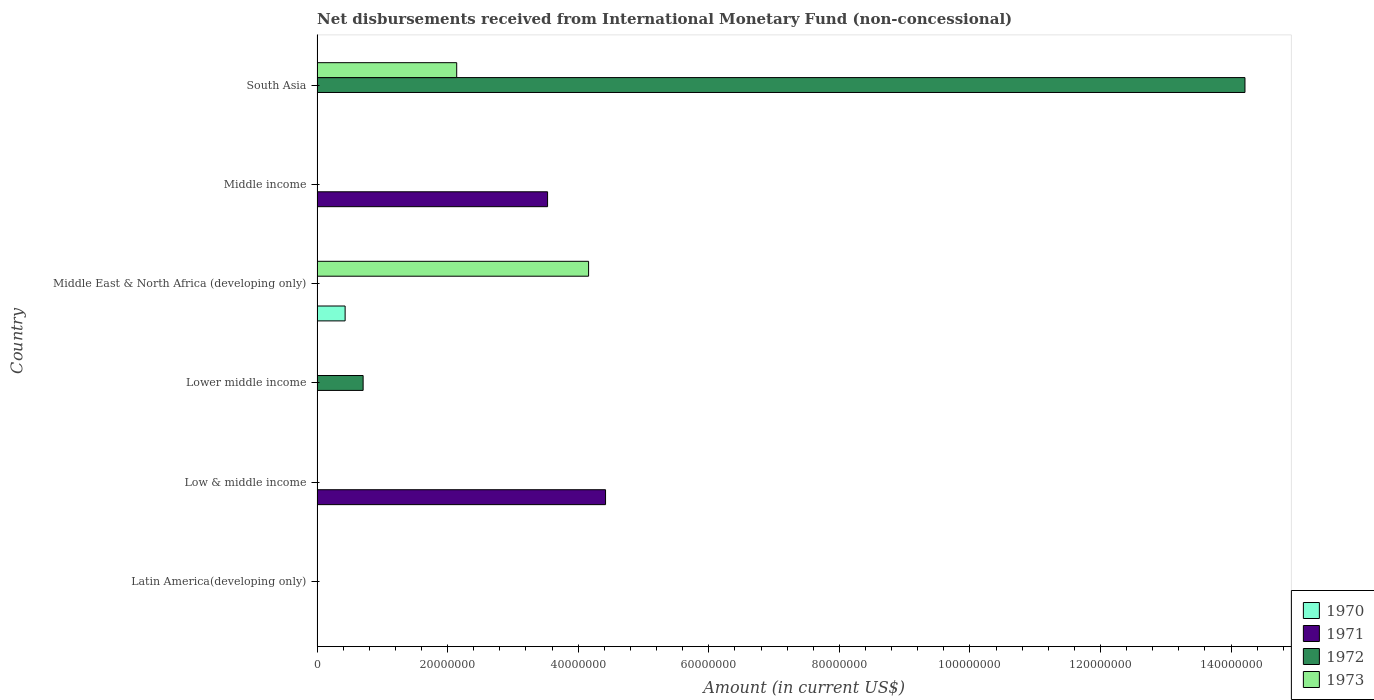How many different coloured bars are there?
Keep it short and to the point. 4. Are the number of bars per tick equal to the number of legend labels?
Provide a short and direct response. No. Are the number of bars on each tick of the Y-axis equal?
Ensure brevity in your answer.  No. Across all countries, what is the maximum amount of disbursements received from International Monetary Fund in 1972?
Your response must be concise. 1.42e+08. In which country was the amount of disbursements received from International Monetary Fund in 1971 maximum?
Your response must be concise. Low & middle income. What is the total amount of disbursements received from International Monetary Fund in 1970 in the graph?
Provide a short and direct response. 4.30e+06. What is the difference between the amount of disbursements received from International Monetary Fund in 1973 in South Asia and the amount of disbursements received from International Monetary Fund in 1972 in Middle income?
Your response must be concise. 2.14e+07. What is the average amount of disbursements received from International Monetary Fund in 1971 per country?
Provide a succinct answer. 1.32e+07. What is the difference between the amount of disbursements received from International Monetary Fund in 1973 and amount of disbursements received from International Monetary Fund in 1972 in South Asia?
Make the answer very short. -1.21e+08. What is the ratio of the amount of disbursements received from International Monetary Fund in 1971 in Low & middle income to that in Middle income?
Offer a terse response. 1.25. What is the difference between the highest and the lowest amount of disbursements received from International Monetary Fund in 1970?
Your answer should be very brief. 4.30e+06. Is it the case that in every country, the sum of the amount of disbursements received from International Monetary Fund in 1971 and amount of disbursements received from International Monetary Fund in 1972 is greater than the sum of amount of disbursements received from International Monetary Fund in 1970 and amount of disbursements received from International Monetary Fund in 1973?
Provide a succinct answer. No. Is it the case that in every country, the sum of the amount of disbursements received from International Monetary Fund in 1971 and amount of disbursements received from International Monetary Fund in 1972 is greater than the amount of disbursements received from International Monetary Fund in 1970?
Provide a short and direct response. No. How many bars are there?
Ensure brevity in your answer.  7. Are all the bars in the graph horizontal?
Your response must be concise. Yes. Are the values on the major ticks of X-axis written in scientific E-notation?
Offer a terse response. No. Does the graph contain any zero values?
Ensure brevity in your answer.  Yes. Does the graph contain grids?
Offer a very short reply. No. Where does the legend appear in the graph?
Ensure brevity in your answer.  Bottom right. How many legend labels are there?
Your answer should be very brief. 4. What is the title of the graph?
Your response must be concise. Net disbursements received from International Monetary Fund (non-concessional). What is the label or title of the X-axis?
Offer a terse response. Amount (in current US$). What is the Amount (in current US$) in 1970 in Latin America(developing only)?
Your answer should be compact. 0. What is the Amount (in current US$) in 1972 in Latin America(developing only)?
Keep it short and to the point. 0. What is the Amount (in current US$) in 1973 in Latin America(developing only)?
Make the answer very short. 0. What is the Amount (in current US$) of 1971 in Low & middle income?
Provide a succinct answer. 4.42e+07. What is the Amount (in current US$) in 1971 in Lower middle income?
Your answer should be very brief. 0. What is the Amount (in current US$) of 1972 in Lower middle income?
Offer a terse response. 7.06e+06. What is the Amount (in current US$) of 1973 in Lower middle income?
Provide a short and direct response. 0. What is the Amount (in current US$) of 1970 in Middle East & North Africa (developing only)?
Provide a short and direct response. 4.30e+06. What is the Amount (in current US$) of 1971 in Middle East & North Africa (developing only)?
Offer a very short reply. 0. What is the Amount (in current US$) of 1972 in Middle East & North Africa (developing only)?
Offer a terse response. 0. What is the Amount (in current US$) of 1973 in Middle East & North Africa (developing only)?
Your answer should be compact. 4.16e+07. What is the Amount (in current US$) of 1970 in Middle income?
Make the answer very short. 0. What is the Amount (in current US$) in 1971 in Middle income?
Give a very brief answer. 3.53e+07. What is the Amount (in current US$) in 1972 in Middle income?
Make the answer very short. 0. What is the Amount (in current US$) in 1972 in South Asia?
Your response must be concise. 1.42e+08. What is the Amount (in current US$) of 1973 in South Asia?
Give a very brief answer. 2.14e+07. Across all countries, what is the maximum Amount (in current US$) in 1970?
Your response must be concise. 4.30e+06. Across all countries, what is the maximum Amount (in current US$) of 1971?
Keep it short and to the point. 4.42e+07. Across all countries, what is the maximum Amount (in current US$) of 1972?
Provide a short and direct response. 1.42e+08. Across all countries, what is the maximum Amount (in current US$) in 1973?
Keep it short and to the point. 4.16e+07. Across all countries, what is the minimum Amount (in current US$) in 1971?
Provide a succinct answer. 0. Across all countries, what is the minimum Amount (in current US$) of 1972?
Your answer should be very brief. 0. Across all countries, what is the minimum Amount (in current US$) of 1973?
Your response must be concise. 0. What is the total Amount (in current US$) of 1970 in the graph?
Your answer should be compact. 4.30e+06. What is the total Amount (in current US$) in 1971 in the graph?
Make the answer very short. 7.95e+07. What is the total Amount (in current US$) of 1972 in the graph?
Your answer should be very brief. 1.49e+08. What is the total Amount (in current US$) in 1973 in the graph?
Ensure brevity in your answer.  6.30e+07. What is the difference between the Amount (in current US$) in 1971 in Low & middle income and that in Middle income?
Ensure brevity in your answer.  8.88e+06. What is the difference between the Amount (in current US$) of 1972 in Lower middle income and that in South Asia?
Keep it short and to the point. -1.35e+08. What is the difference between the Amount (in current US$) of 1973 in Middle East & North Africa (developing only) and that in South Asia?
Provide a short and direct response. 2.02e+07. What is the difference between the Amount (in current US$) of 1971 in Low & middle income and the Amount (in current US$) of 1972 in Lower middle income?
Offer a very short reply. 3.71e+07. What is the difference between the Amount (in current US$) of 1971 in Low & middle income and the Amount (in current US$) of 1973 in Middle East & North Africa (developing only)?
Make the answer very short. 2.60e+06. What is the difference between the Amount (in current US$) in 1971 in Low & middle income and the Amount (in current US$) in 1972 in South Asia?
Keep it short and to the point. -9.79e+07. What is the difference between the Amount (in current US$) in 1971 in Low & middle income and the Amount (in current US$) in 1973 in South Asia?
Make the answer very short. 2.28e+07. What is the difference between the Amount (in current US$) in 1972 in Lower middle income and the Amount (in current US$) in 1973 in Middle East & North Africa (developing only)?
Your answer should be compact. -3.45e+07. What is the difference between the Amount (in current US$) in 1972 in Lower middle income and the Amount (in current US$) in 1973 in South Asia?
Make the answer very short. -1.43e+07. What is the difference between the Amount (in current US$) of 1970 in Middle East & North Africa (developing only) and the Amount (in current US$) of 1971 in Middle income?
Your answer should be very brief. -3.10e+07. What is the difference between the Amount (in current US$) of 1970 in Middle East & North Africa (developing only) and the Amount (in current US$) of 1972 in South Asia?
Make the answer very short. -1.38e+08. What is the difference between the Amount (in current US$) in 1970 in Middle East & North Africa (developing only) and the Amount (in current US$) in 1973 in South Asia?
Make the answer very short. -1.71e+07. What is the difference between the Amount (in current US$) in 1971 in Middle income and the Amount (in current US$) in 1972 in South Asia?
Provide a short and direct response. -1.07e+08. What is the difference between the Amount (in current US$) in 1971 in Middle income and the Amount (in current US$) in 1973 in South Asia?
Provide a succinct answer. 1.39e+07. What is the average Amount (in current US$) of 1970 per country?
Your answer should be compact. 7.17e+05. What is the average Amount (in current US$) in 1971 per country?
Offer a very short reply. 1.32e+07. What is the average Amount (in current US$) in 1972 per country?
Keep it short and to the point. 2.49e+07. What is the average Amount (in current US$) of 1973 per country?
Give a very brief answer. 1.05e+07. What is the difference between the Amount (in current US$) in 1970 and Amount (in current US$) in 1973 in Middle East & North Africa (developing only)?
Offer a very short reply. -3.73e+07. What is the difference between the Amount (in current US$) in 1972 and Amount (in current US$) in 1973 in South Asia?
Keep it short and to the point. 1.21e+08. What is the ratio of the Amount (in current US$) of 1971 in Low & middle income to that in Middle income?
Your answer should be very brief. 1.25. What is the ratio of the Amount (in current US$) in 1972 in Lower middle income to that in South Asia?
Your response must be concise. 0.05. What is the ratio of the Amount (in current US$) of 1973 in Middle East & North Africa (developing only) to that in South Asia?
Keep it short and to the point. 1.94. What is the difference between the highest and the lowest Amount (in current US$) of 1970?
Give a very brief answer. 4.30e+06. What is the difference between the highest and the lowest Amount (in current US$) in 1971?
Provide a succinct answer. 4.42e+07. What is the difference between the highest and the lowest Amount (in current US$) in 1972?
Offer a terse response. 1.42e+08. What is the difference between the highest and the lowest Amount (in current US$) in 1973?
Provide a succinct answer. 4.16e+07. 